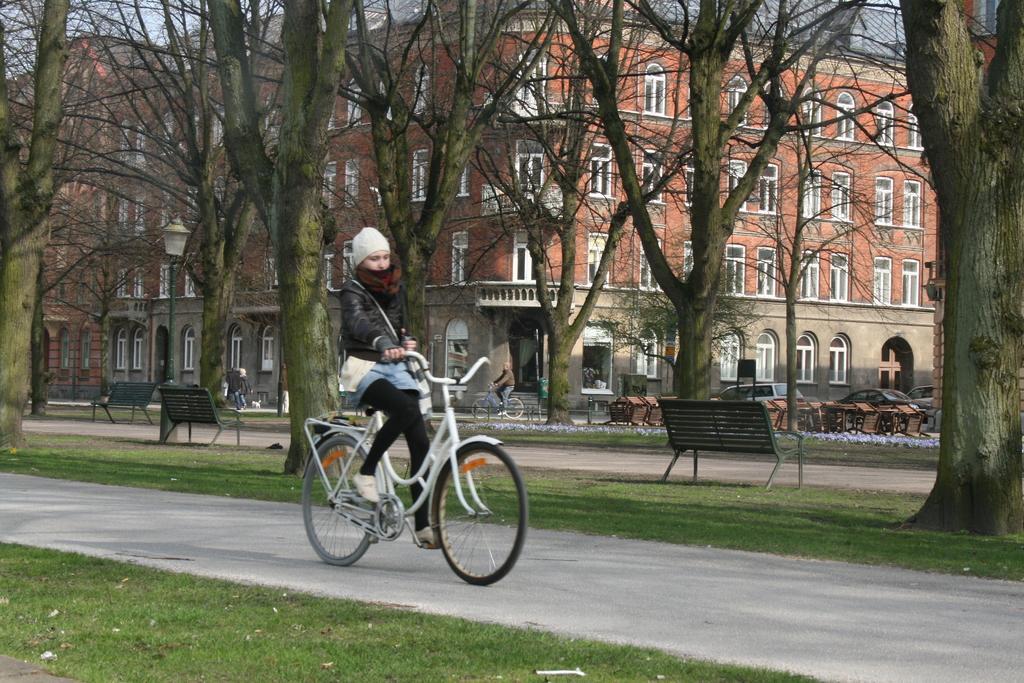How would you summarize this image in a sentence or two? In the picture of a girl riding a bicycle on the road there are many trees near to the road there are benches it seems to be a park there are cars on the road there is a building. 